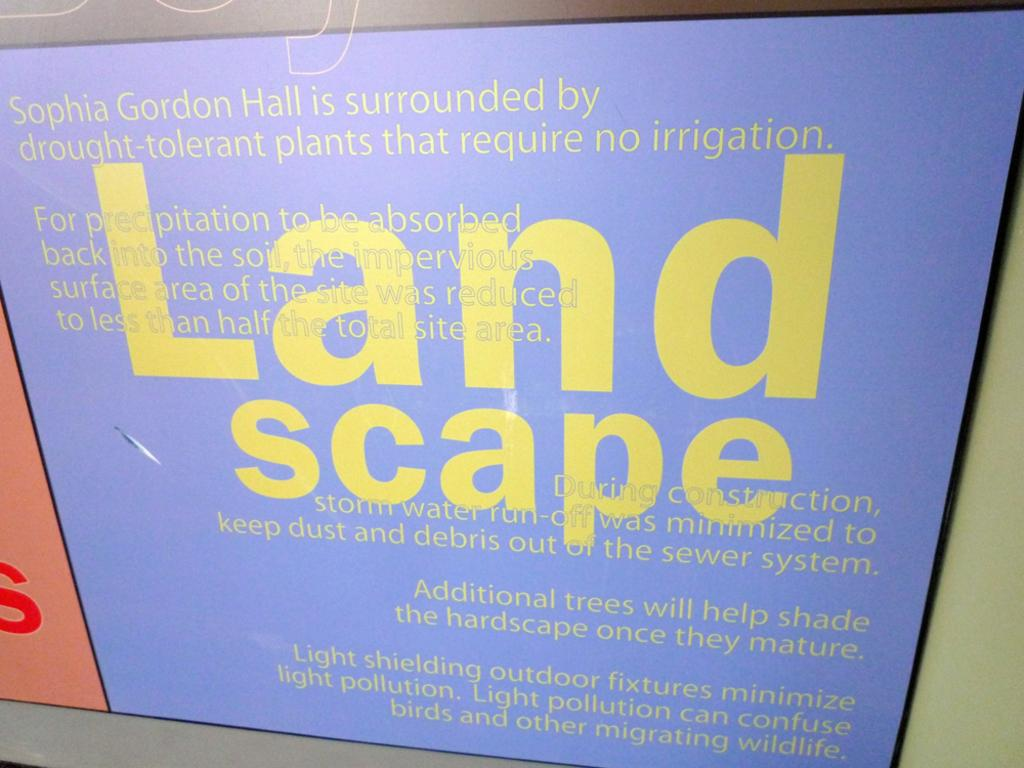<image>
Give a short and clear explanation of the subsequent image. A sign informs visitors of the contents of an area's landscape. 